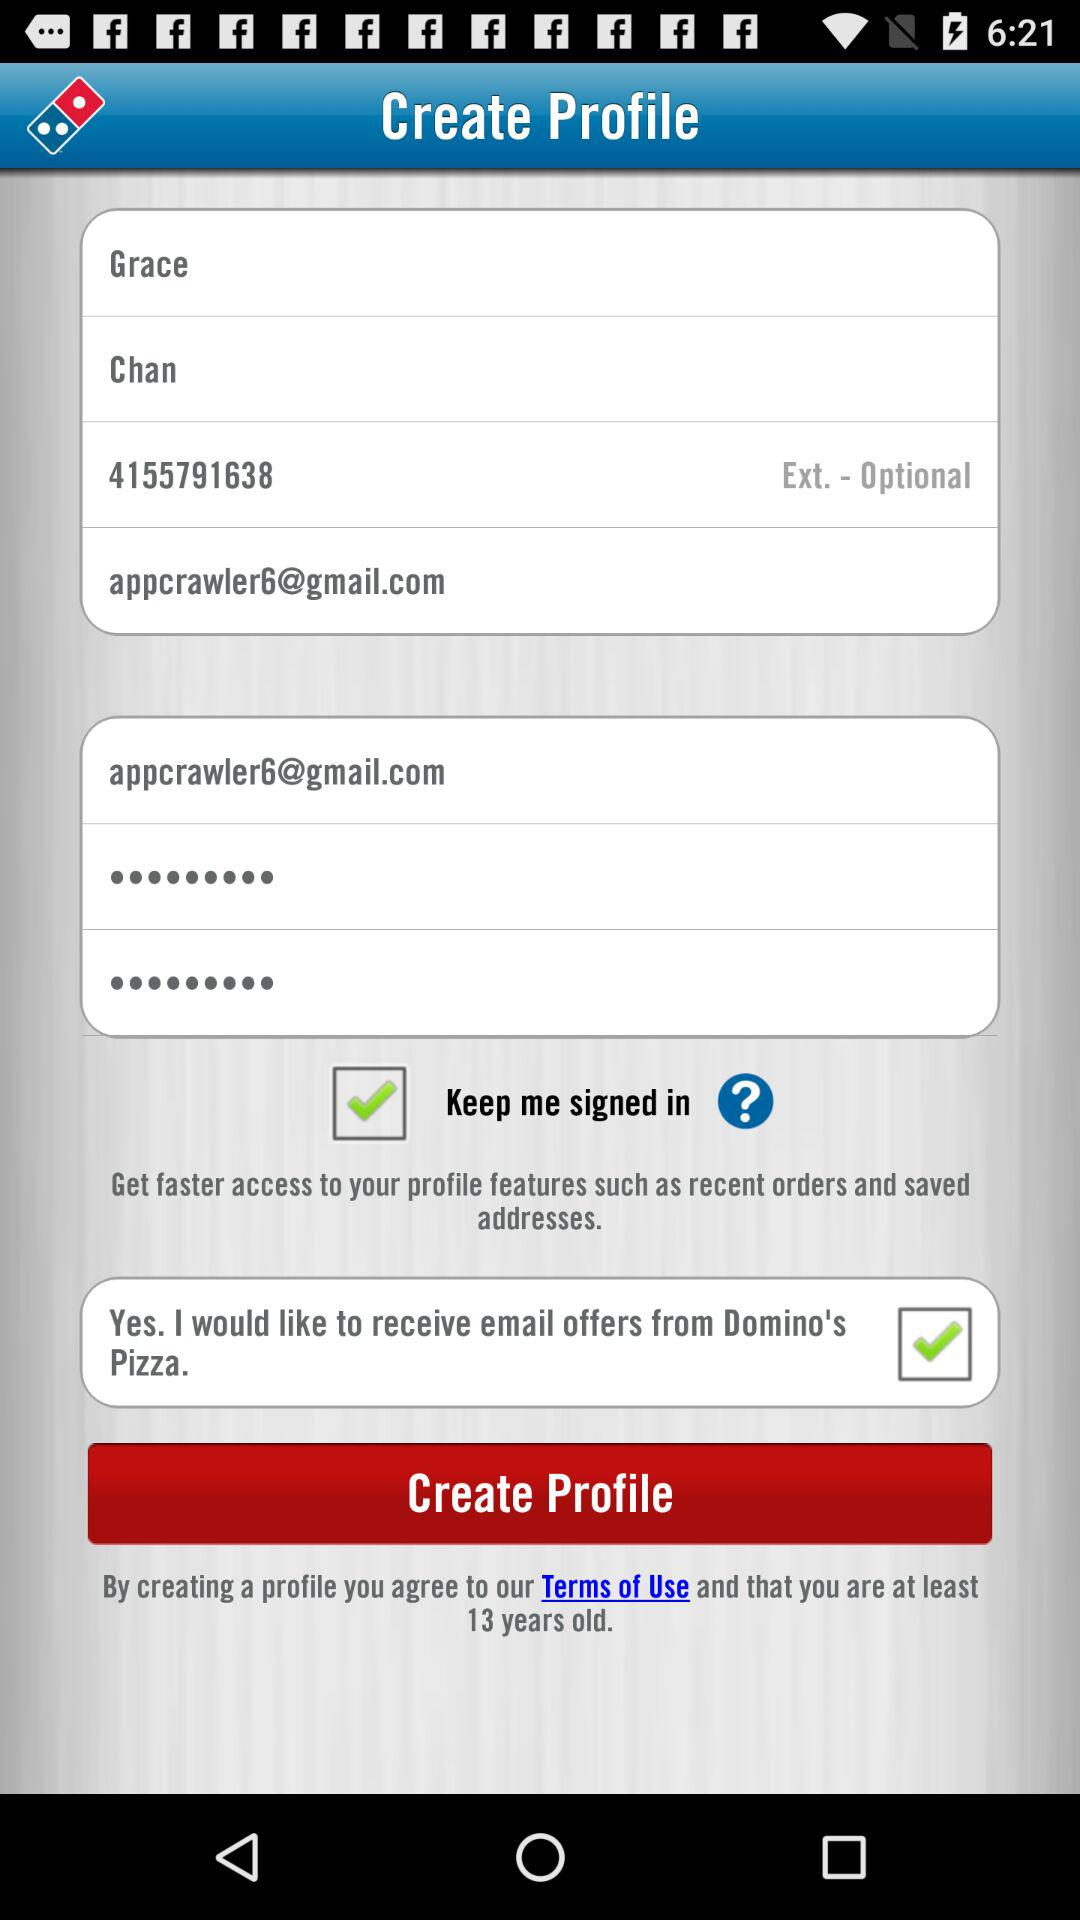What is the given first name? The first name is Grace. 